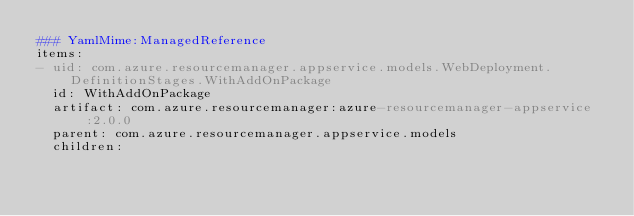<code> <loc_0><loc_0><loc_500><loc_500><_YAML_>### YamlMime:ManagedReference
items:
- uid: com.azure.resourcemanager.appservice.models.WebDeployment.DefinitionStages.WithAddOnPackage
  id: WithAddOnPackage
  artifact: com.azure.resourcemanager:azure-resourcemanager-appservice:2.0.0
  parent: com.azure.resourcemanager.appservice.models
  children:</code> 